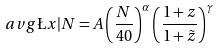Convert formula to latex. <formula><loc_0><loc_0><loc_500><loc_500>\ a v g { \L x | N } = A \left ( \frac { N } { 4 0 } \right ) ^ { \alpha } \left ( \frac { 1 + z } { 1 + \tilde { z } } \right ) ^ { \gamma }</formula> 